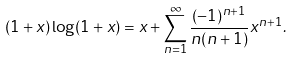<formula> <loc_0><loc_0><loc_500><loc_500>( 1 + x ) \log ( 1 + x ) = x + \sum _ { n = 1 } ^ { \infty } \frac { ( - 1 ) ^ { n + 1 } } { n ( n + 1 ) } x ^ { n + 1 } .</formula> 